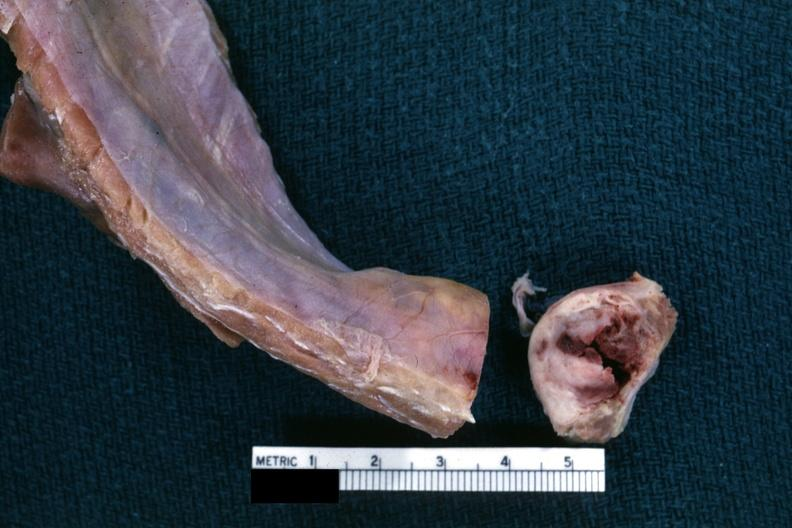how is obvious nodular rib lesion cross sectioned to show white neoplasm with hemorrhage?
Answer the question using a single word or phrase. Central 